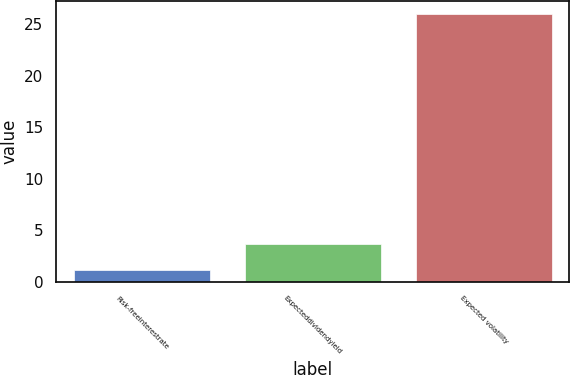Convert chart. <chart><loc_0><loc_0><loc_500><loc_500><bar_chart><fcel>Risk-freeinterestrate<fcel>Expecteddividendyield<fcel>Expected volatility<nl><fcel>1.16<fcel>3.64<fcel>26<nl></chart> 